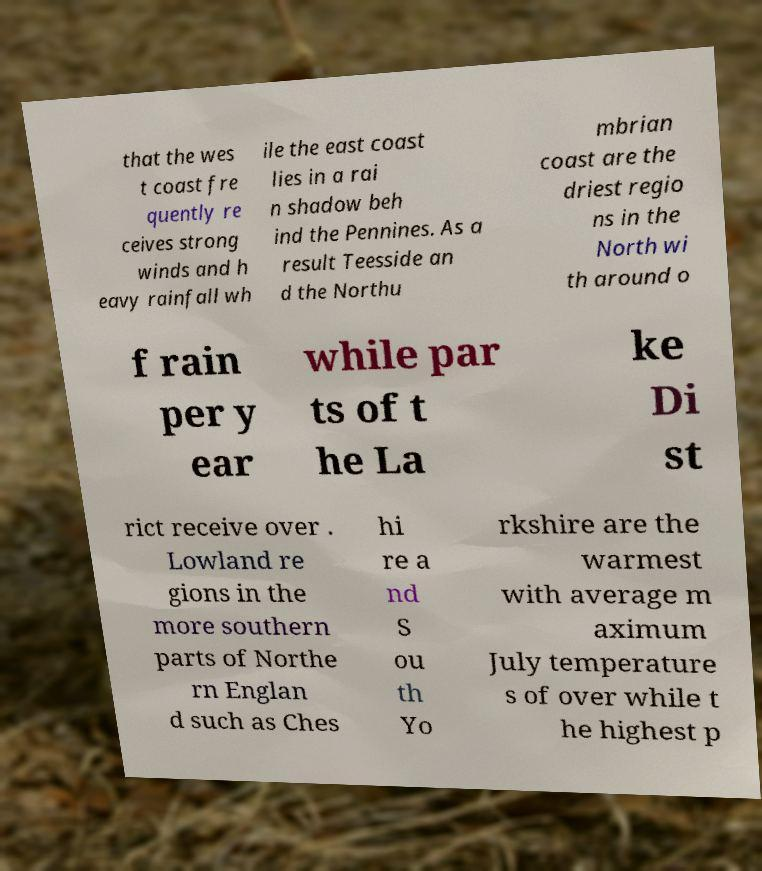Can you accurately transcribe the text from the provided image for me? that the wes t coast fre quently re ceives strong winds and h eavy rainfall wh ile the east coast lies in a rai n shadow beh ind the Pennines. As a result Teesside an d the Northu mbrian coast are the driest regio ns in the North wi th around o f rain per y ear while par ts of t he La ke Di st rict receive over . Lowland re gions in the more southern parts of Northe rn Englan d such as Ches hi re a nd S ou th Yo rkshire are the warmest with average m aximum July temperature s of over while t he highest p 